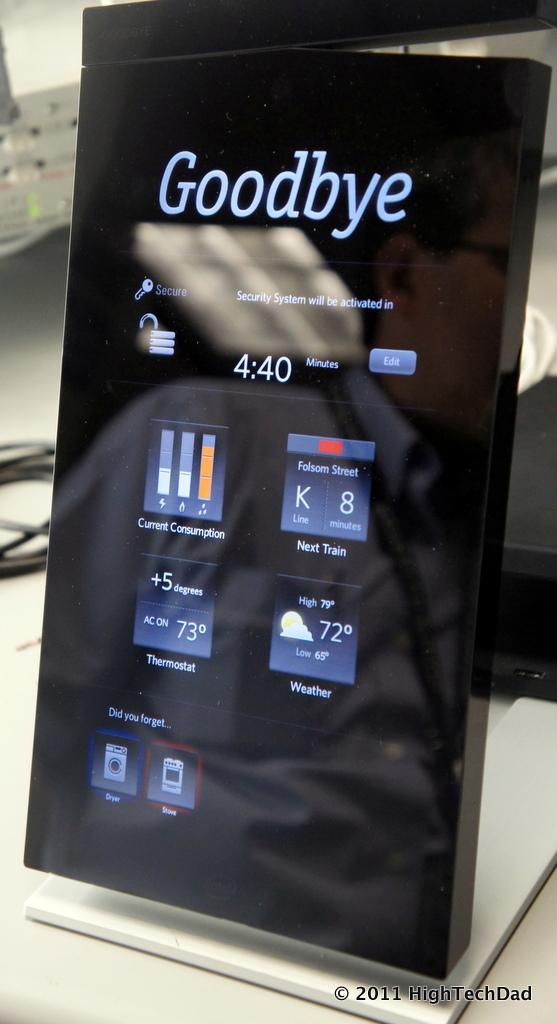Provide a one-sentence caption for the provided image. A digitial displaying showing statistics controls around the home such as a/c temperature and laundry settings. 